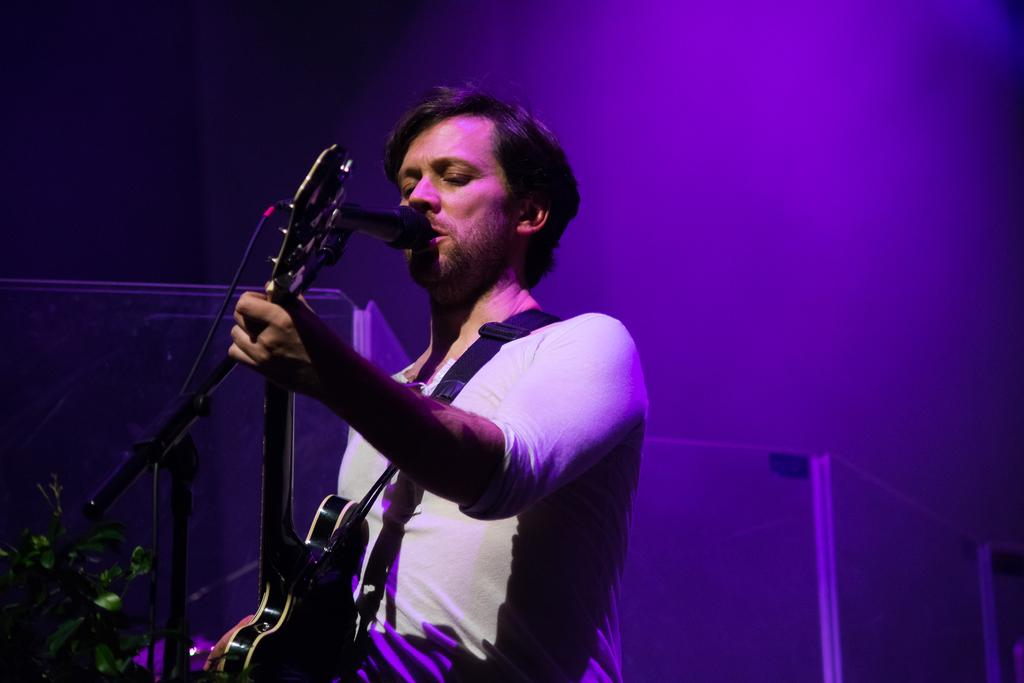What is the main subject of the image? There is a person in the image. What is the person doing in the image? The person is standing and singing. What instrument is the person playing in the image? The person is playing a guitar. What type of holiday is the person celebrating in the image? There is no indication of a holiday in the image; it simply shows a person playing a guitar and singing. Can you see any waves in the image? There are no waves present in the image. 